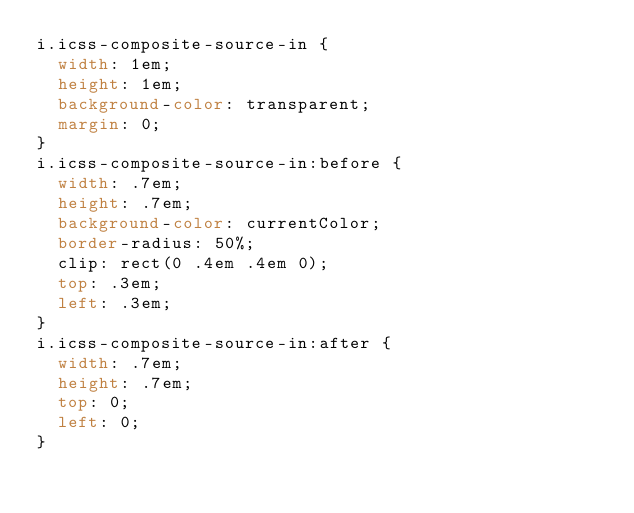<code> <loc_0><loc_0><loc_500><loc_500><_CSS_>i.icss-composite-source-in {
  width: 1em;
  height: 1em;
  background-color: transparent;
  margin: 0;
}
i.icss-composite-source-in:before {
  width: .7em;
  height: .7em;
  background-color: currentColor;
  border-radius: 50%;
  clip: rect(0 .4em .4em 0);
  top: .3em;
  left: .3em;
}
i.icss-composite-source-in:after {
  width: .7em;
  height: .7em;
  top: 0;
  left: 0;
}</code> 